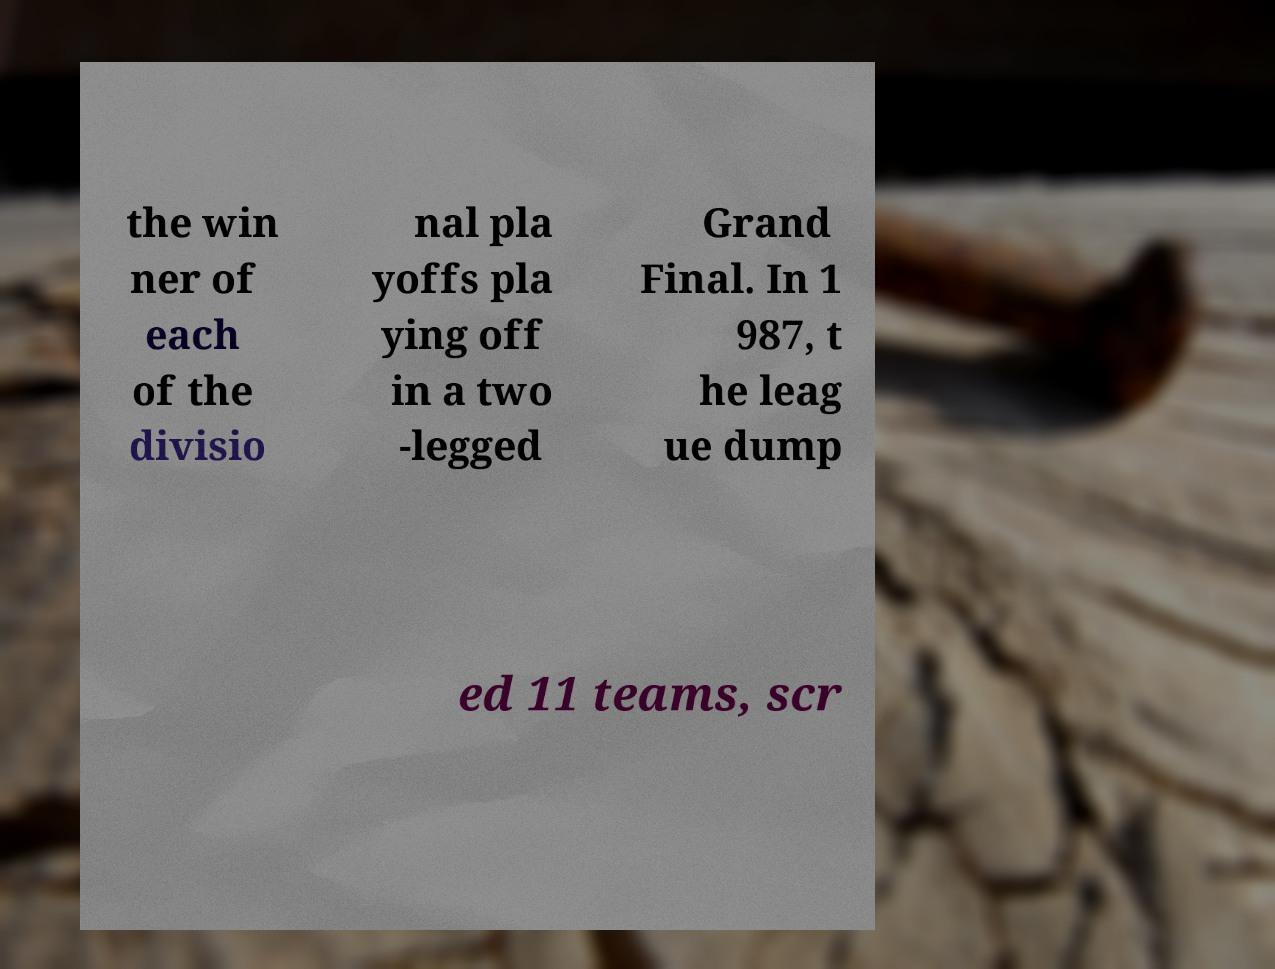Could you extract and type out the text from this image? the win ner of each of the divisio nal pla yoffs pla ying off in a two -legged Grand Final. In 1 987, t he leag ue dump ed 11 teams, scr 